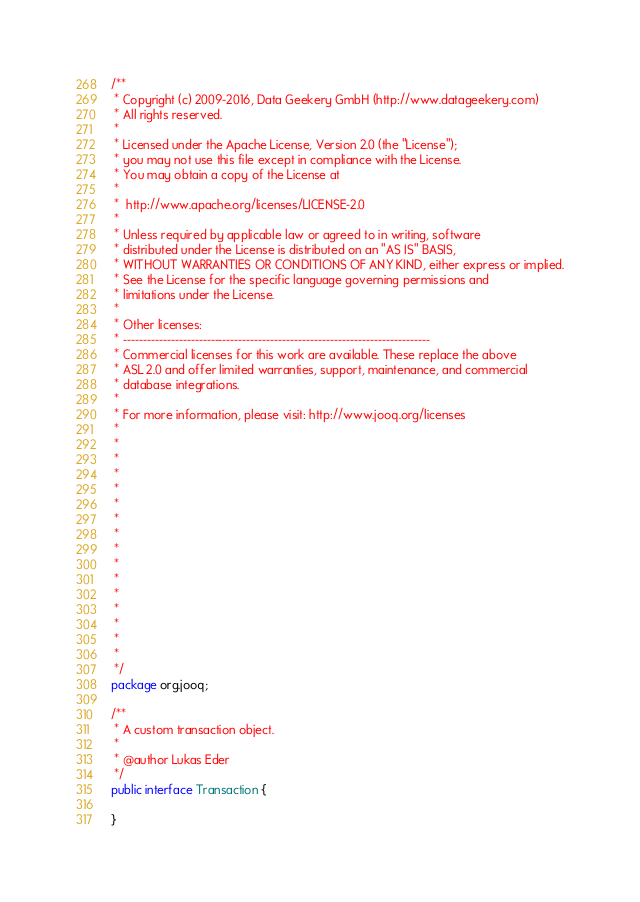<code> <loc_0><loc_0><loc_500><loc_500><_Java_>/**
 * Copyright (c) 2009-2016, Data Geekery GmbH (http://www.datageekery.com)
 * All rights reserved.
 *
 * Licensed under the Apache License, Version 2.0 (the "License");
 * you may not use this file except in compliance with the License.
 * You may obtain a copy of the License at
 *
 *  http://www.apache.org/licenses/LICENSE-2.0
 *
 * Unless required by applicable law or agreed to in writing, software
 * distributed under the License is distributed on an "AS IS" BASIS,
 * WITHOUT WARRANTIES OR CONDITIONS OF ANY KIND, either express or implied.
 * See the License for the specific language governing permissions and
 * limitations under the License.
 *
 * Other licenses:
 * -----------------------------------------------------------------------------
 * Commercial licenses for this work are available. These replace the above
 * ASL 2.0 and offer limited warranties, support, maintenance, and commercial
 * database integrations.
 *
 * For more information, please visit: http://www.jooq.org/licenses
 *
 *
 *
 *
 *
 *
 *
 *
 *
 *
 *
 *
 *
 *
 *
 *
 */
package org.jooq;

/**
 * A custom transaction object.
 *
 * @author Lukas Eder
 */
public interface Transaction {

}
</code> 